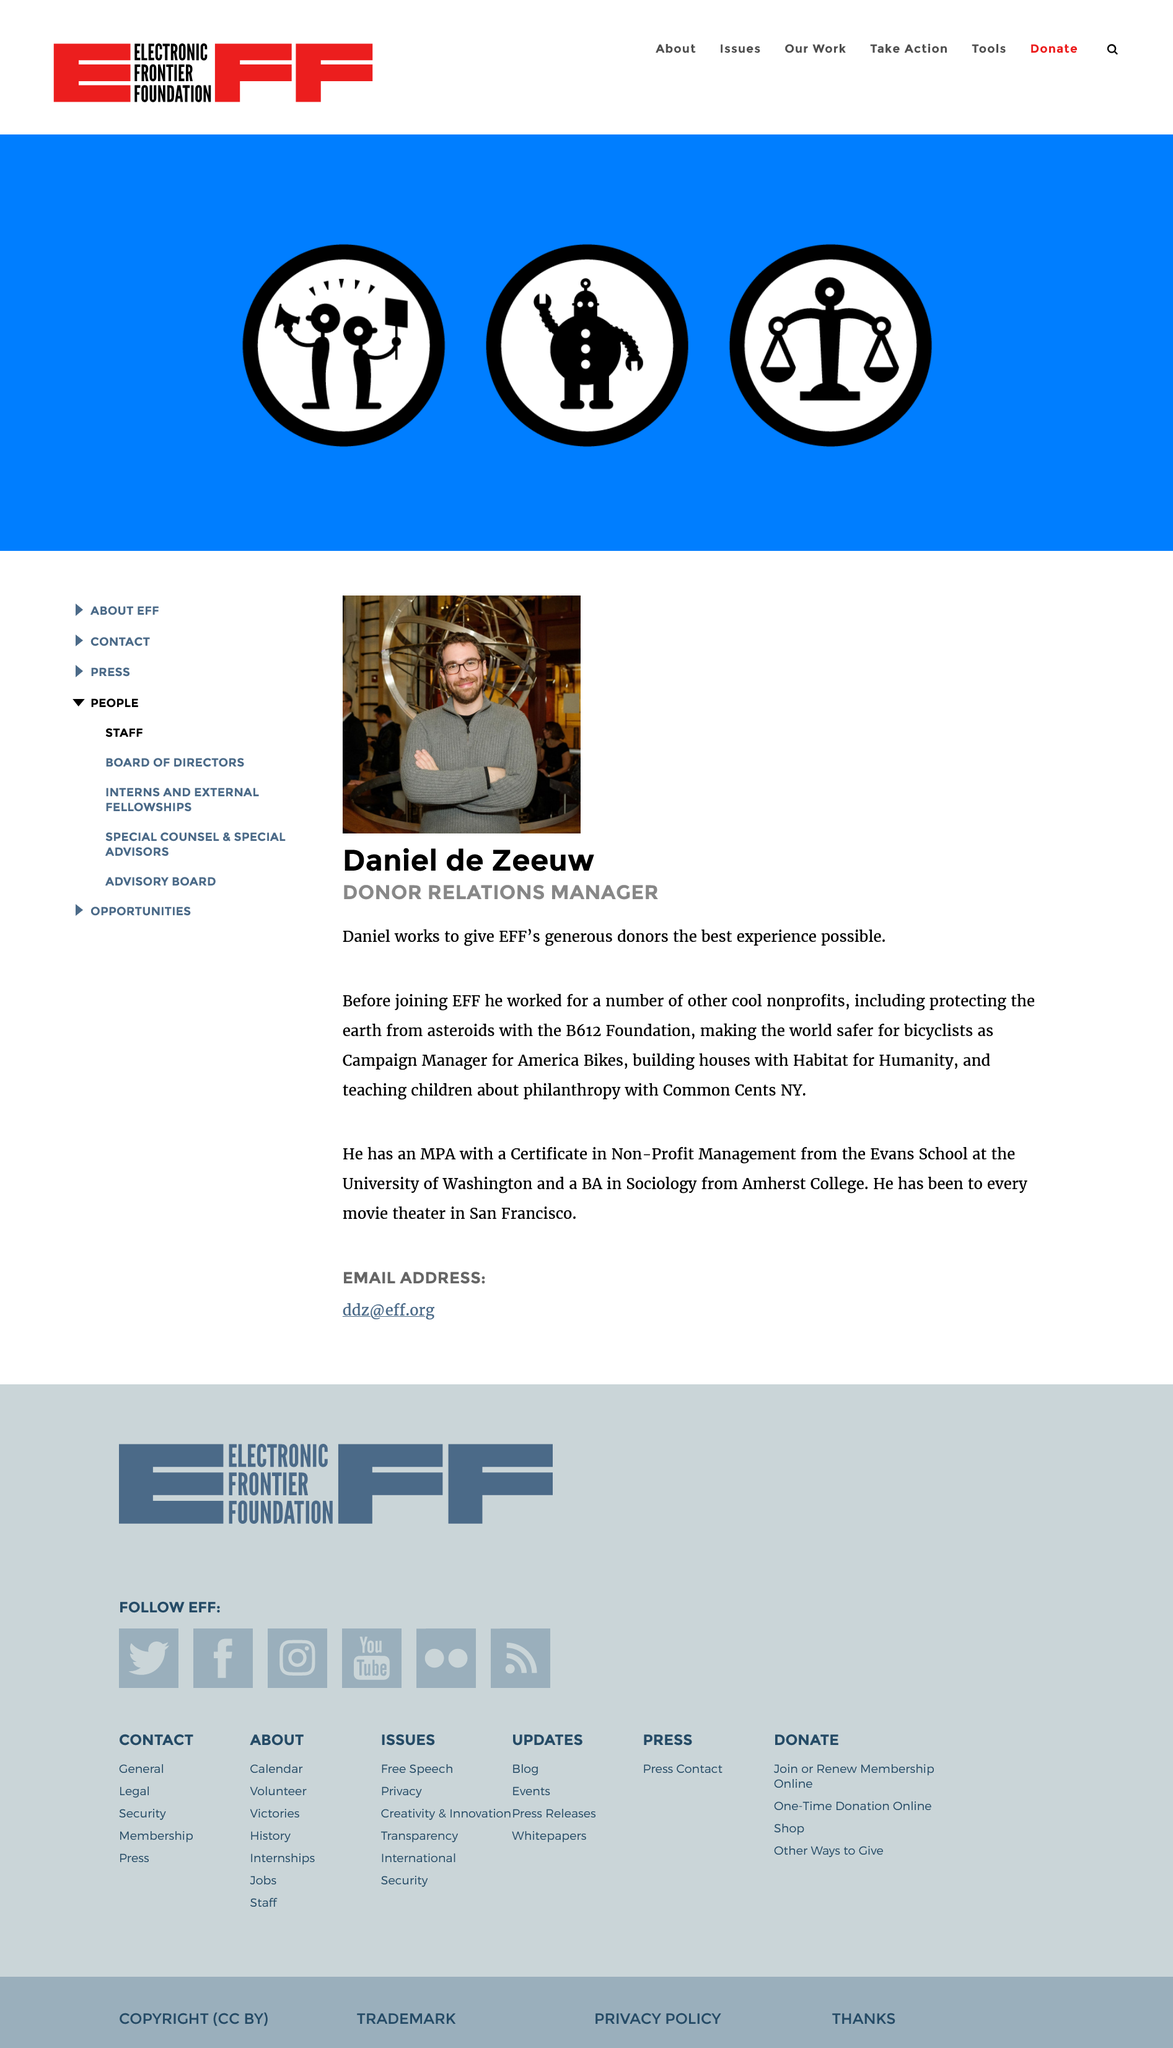Draw attention to some important aspects in this diagram. Daniel de Zeeuw obtained his Master in Public Administration degree from the Evans School at the University of Washington. Daniel is a Donor Relations Manager. This page is about Daniel de Zeeuw. 